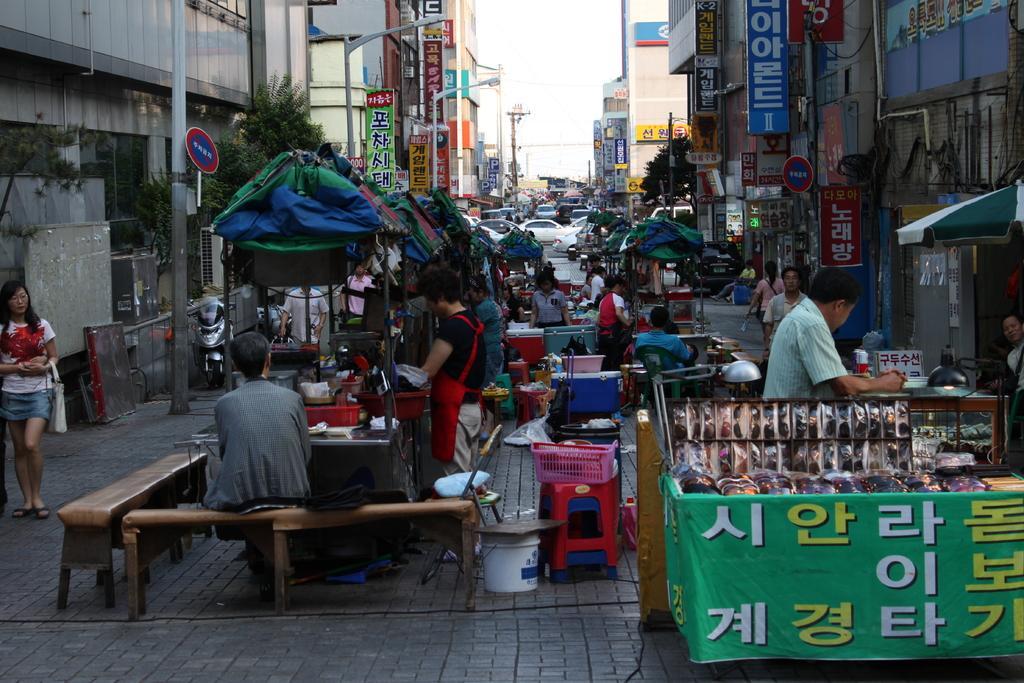Can you describe this image briefly? In this image there is the sky, there are building towards the right of the image, there are building towards the left of the image, there are vehicles, there are group of persons, there are benches, there are objects on the ground, there are shops, there is an umbrella truncated towards the right of the image, there is a person truncated towards the right of the image, there are poles, there is a light, there are boards, there is text on the boards, there is a banner truncated towards the right of the image. 